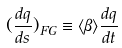Convert formula to latex. <formula><loc_0><loc_0><loc_500><loc_500>( \frac { d q } { d s } ) _ { F G } \equiv \langle \beta \rangle \frac { d q } { d t }</formula> 